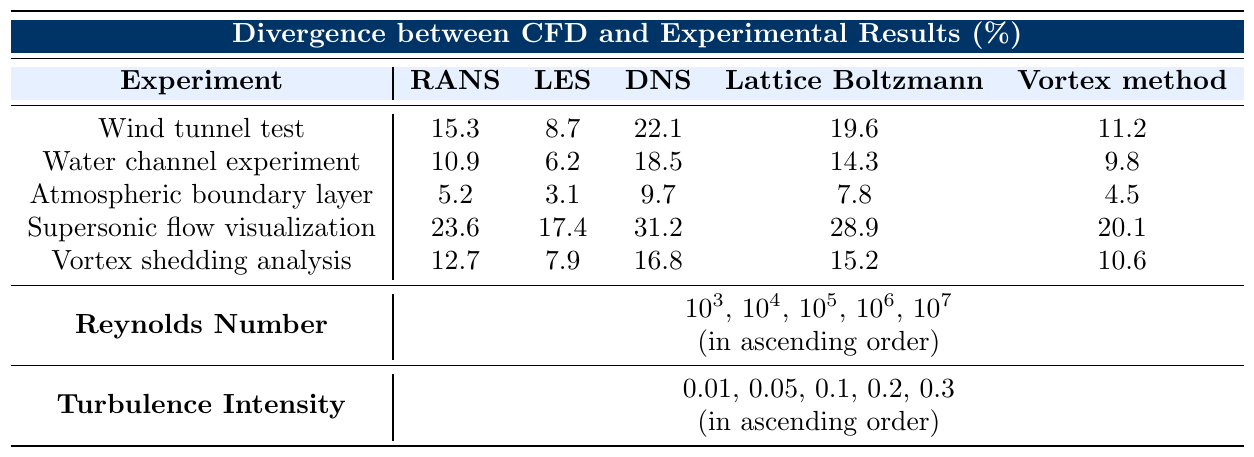What is the divergence for the Atmospheric Boundary Layer using the LES model? Referring to the table, locate the row for the Atmospheric Boundary Layer and find the column for the LES model, which shows a divergence of 3.1%.
Answer: 3.1% Which experimental scenario exhibits the highest divergence when using the DNS model? By looking at the DNS column, the highest value is found in the Supersonic Flow Visualization row, showing a divergence of 31.2%.
Answer: 31.2% Calculate the average divergence from the Water Channel Experiment across all CFD models. The divergences for the Water Channel Experiment are 10.9, 6.2, 18.5, 14.3, and 9.8. Summing these gives 10.9 + 6.2 + 18.5 + 14.3 + 9.8 = 59.7. Dividing by the number of models (5) results in an average of 11.94%.
Answer: 11.94% Does the Lattice Boltzmann method perform better than the RANS method in the Supersonic Flow Visualization? The divergences for Supersonic Flow Visualization are 23.6% for RANS and 28.9% for Lattice Boltzmann. Since 23.6% is less than 28.9%, RANS performs better.
Answer: No What is the total divergence for the Vortex Shedding Analysis across all models? Summing the divergences for Vortex Shedding Analysis gives 12.7 + 7.9 + 16.8 + 15.2 + 10.6 = 63.2%.
Answer: 63.2% Which CFD model shows the least divergence on average across all experiments? To find this, we need to average each model's divergences. RANS: (15.3 + 10.9 + 5.2 + 23.6 + 12.7) = 68.7, so 68.7/5 = 13.74%. LES: (8.7 + 6.2 + 3.1 + 17.4 + 7.9) = 43.3, so 43.3/5 = 8.66%. DNS: (22.1 + 18.5 + 9.7 + 31.2 + 16.8) = 98.3, so 98.3/5 = 19.66%. Lattice Boltzmann: (19.6 + 14.3 + 7.8 + 28.9 + 15.2) = 85.8, so 85.8/5 = 17.16%. Vortex method: (11.2 + 9.8 + 4.5 + 20.1 + 10.6) = 66.2, so 66.2/5 = 13.24%. The model with the least average divergence is LES at 8.66%.
Answer: LES What is the maximum discrepancy found in the Water Channel Experiment? Looking at the Water Channel Experiment row, the maximum discrepancy is 18.5% in the DNS model.
Answer: 18.5% Which experimental scenario has the smallest divergence when using the RANS model? Checking the RANS column, the smallest divergence is found in the Atmospheric Boundary Layer row, showing 5.2%.
Answer: 5.2% Is there a consistent pattern in how turbulence intensity affects divergence across different models? Analyzing the data, turbulence intensity does not show a consistent trend affecting all models similarly; some models show increases or decreases at varying turbulence intensities.
Answer: No 